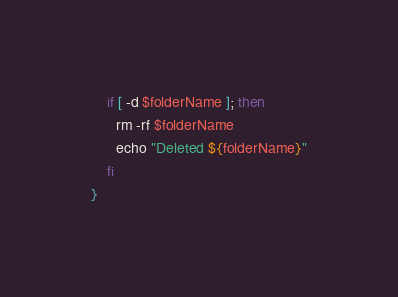Convert code to text. <code><loc_0><loc_0><loc_500><loc_500><_Bash_>
    if [ -d $folderName ]; then
      rm -rf $folderName
      echo "Deleted ${folderName}"
    fi
}</code> 